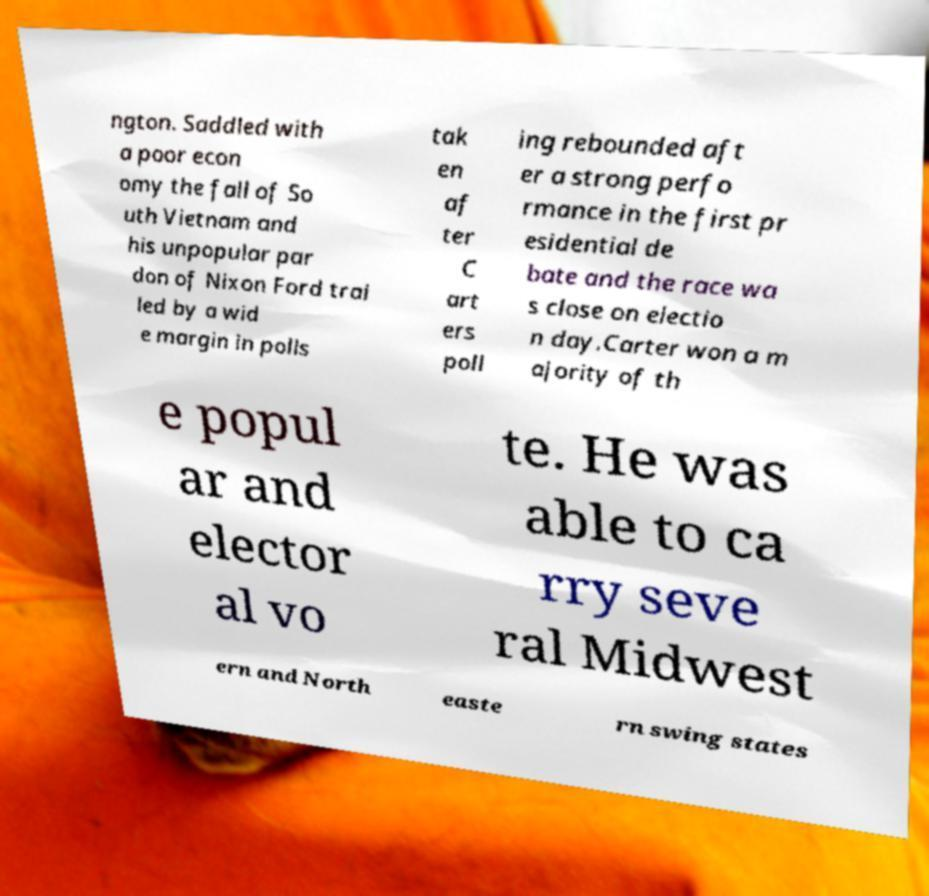Please identify and transcribe the text found in this image. ngton. Saddled with a poor econ omy the fall of So uth Vietnam and his unpopular par don of Nixon Ford trai led by a wid e margin in polls tak en af ter C art ers poll ing rebounded aft er a strong perfo rmance in the first pr esidential de bate and the race wa s close on electio n day.Carter won a m ajority of th e popul ar and elector al vo te. He was able to ca rry seve ral Midwest ern and North easte rn swing states 